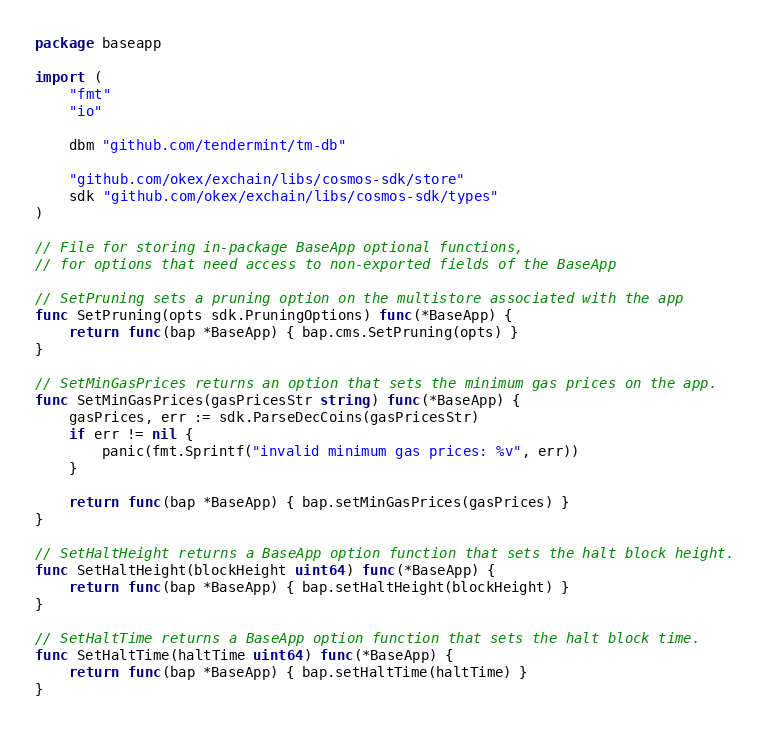Convert code to text. <code><loc_0><loc_0><loc_500><loc_500><_Go_>package baseapp

import (
	"fmt"
	"io"

	dbm "github.com/tendermint/tm-db"

	"github.com/okex/exchain/libs/cosmos-sdk/store"
	sdk "github.com/okex/exchain/libs/cosmos-sdk/types"
)

// File for storing in-package BaseApp optional functions,
// for options that need access to non-exported fields of the BaseApp

// SetPruning sets a pruning option on the multistore associated with the app
func SetPruning(opts sdk.PruningOptions) func(*BaseApp) {
	return func(bap *BaseApp) { bap.cms.SetPruning(opts) }
}

// SetMinGasPrices returns an option that sets the minimum gas prices on the app.
func SetMinGasPrices(gasPricesStr string) func(*BaseApp) {
	gasPrices, err := sdk.ParseDecCoins(gasPricesStr)
	if err != nil {
		panic(fmt.Sprintf("invalid minimum gas prices: %v", err))
	}

	return func(bap *BaseApp) { bap.setMinGasPrices(gasPrices) }
}

// SetHaltHeight returns a BaseApp option function that sets the halt block height.
func SetHaltHeight(blockHeight uint64) func(*BaseApp) {
	return func(bap *BaseApp) { bap.setHaltHeight(blockHeight) }
}

// SetHaltTime returns a BaseApp option function that sets the halt block time.
func SetHaltTime(haltTime uint64) func(*BaseApp) {
	return func(bap *BaseApp) { bap.setHaltTime(haltTime) }
}
</code> 